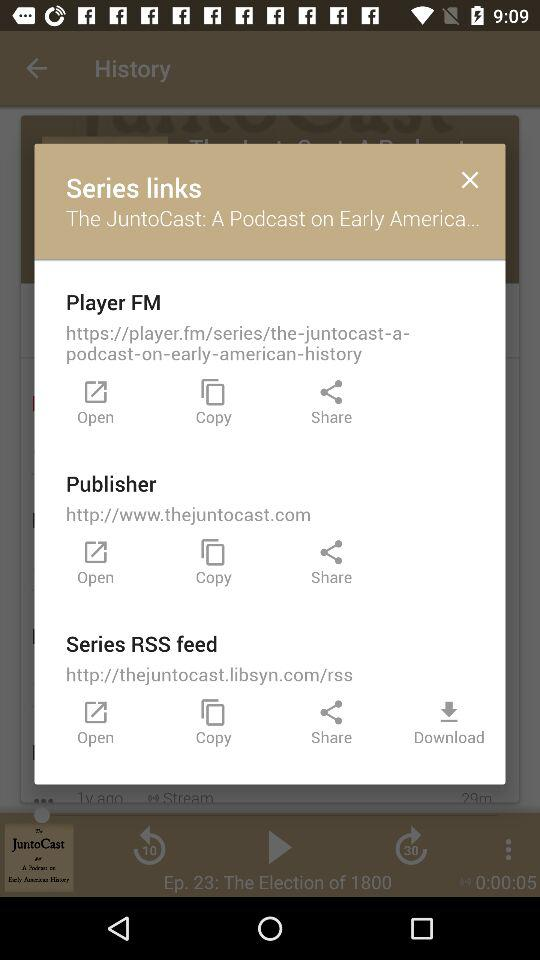How many links to the series are there?
Answer the question using a single word or phrase. 3 